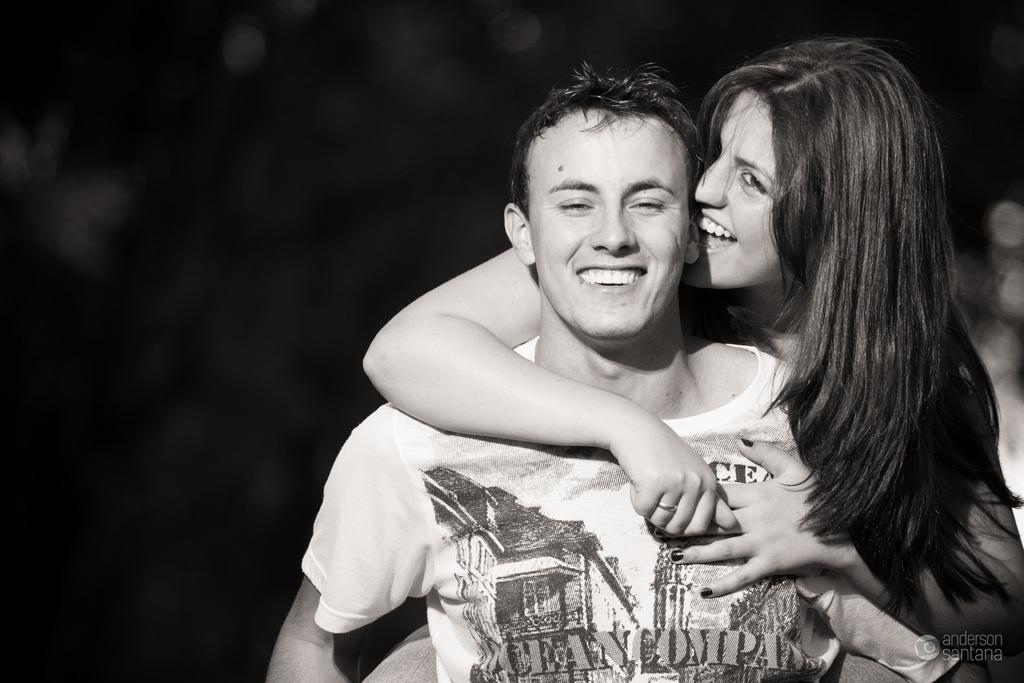How many people are in the image? There are two persons in the image. What can be observed about the background of the image? The background of the image is dark. What type of back support is visible in the image? There is no back support present in the image. What do the two persons in the image believe about a certain topic? The image does not provide any information about the beliefs of the two persons. 